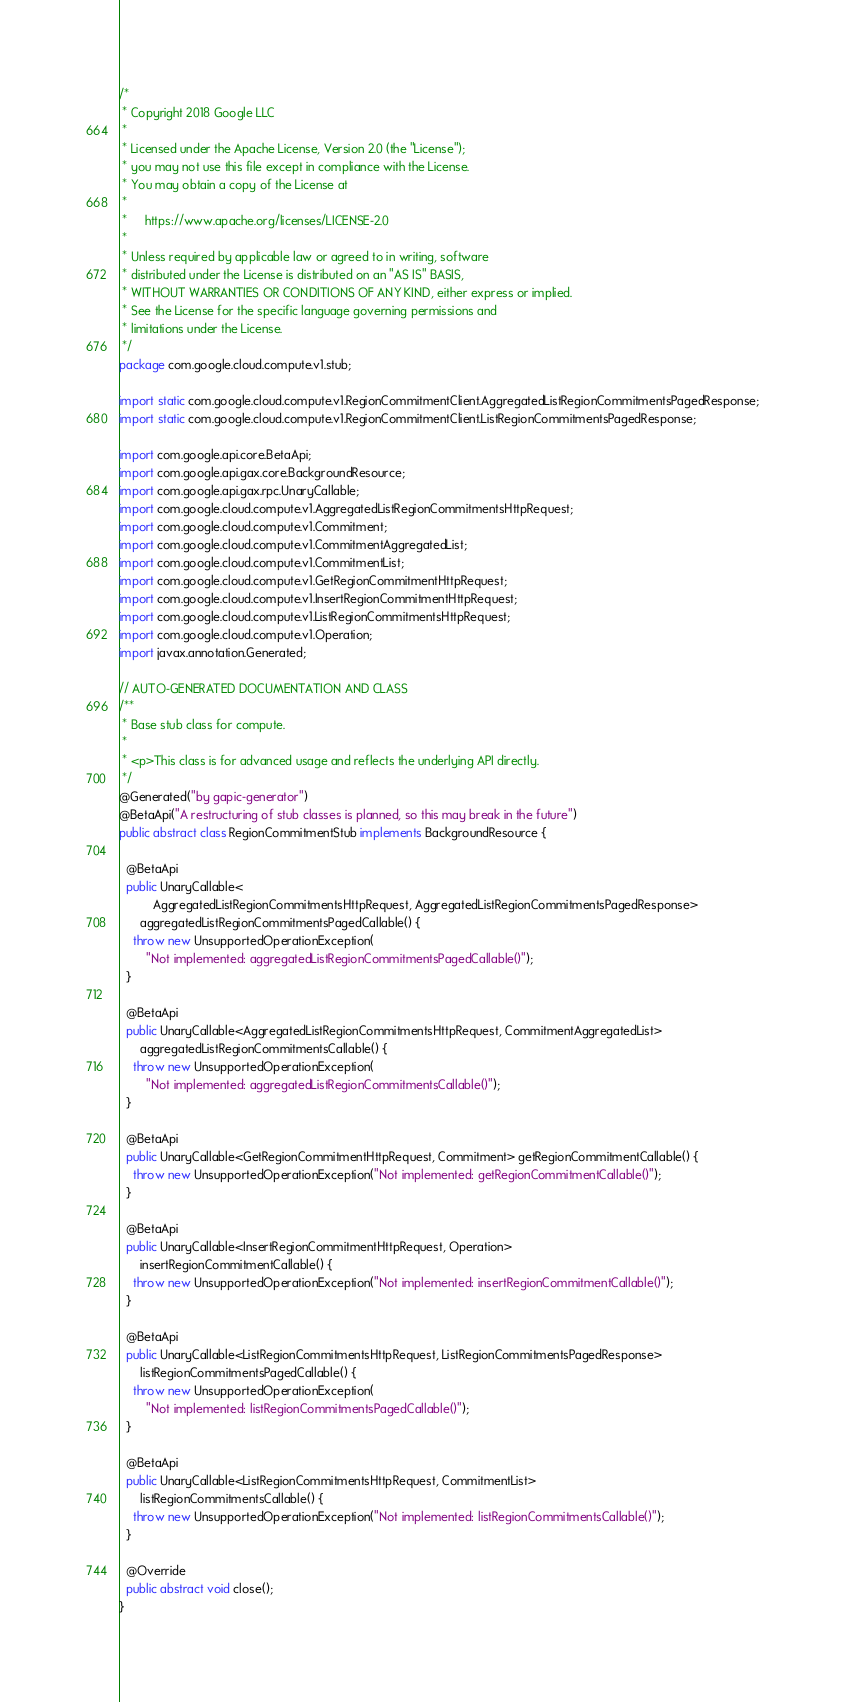Convert code to text. <code><loc_0><loc_0><loc_500><loc_500><_Java_>/*
 * Copyright 2018 Google LLC
 *
 * Licensed under the Apache License, Version 2.0 (the "License");
 * you may not use this file except in compliance with the License.
 * You may obtain a copy of the License at
 *
 *     https://www.apache.org/licenses/LICENSE-2.0
 *
 * Unless required by applicable law or agreed to in writing, software
 * distributed under the License is distributed on an "AS IS" BASIS,
 * WITHOUT WARRANTIES OR CONDITIONS OF ANY KIND, either express or implied.
 * See the License for the specific language governing permissions and
 * limitations under the License.
 */
package com.google.cloud.compute.v1.stub;

import static com.google.cloud.compute.v1.RegionCommitmentClient.AggregatedListRegionCommitmentsPagedResponse;
import static com.google.cloud.compute.v1.RegionCommitmentClient.ListRegionCommitmentsPagedResponse;

import com.google.api.core.BetaApi;
import com.google.api.gax.core.BackgroundResource;
import com.google.api.gax.rpc.UnaryCallable;
import com.google.cloud.compute.v1.AggregatedListRegionCommitmentsHttpRequest;
import com.google.cloud.compute.v1.Commitment;
import com.google.cloud.compute.v1.CommitmentAggregatedList;
import com.google.cloud.compute.v1.CommitmentList;
import com.google.cloud.compute.v1.GetRegionCommitmentHttpRequest;
import com.google.cloud.compute.v1.InsertRegionCommitmentHttpRequest;
import com.google.cloud.compute.v1.ListRegionCommitmentsHttpRequest;
import com.google.cloud.compute.v1.Operation;
import javax.annotation.Generated;

// AUTO-GENERATED DOCUMENTATION AND CLASS
/**
 * Base stub class for compute.
 *
 * <p>This class is for advanced usage and reflects the underlying API directly.
 */
@Generated("by gapic-generator")
@BetaApi("A restructuring of stub classes is planned, so this may break in the future")
public abstract class RegionCommitmentStub implements BackgroundResource {

  @BetaApi
  public UnaryCallable<
          AggregatedListRegionCommitmentsHttpRequest, AggregatedListRegionCommitmentsPagedResponse>
      aggregatedListRegionCommitmentsPagedCallable() {
    throw new UnsupportedOperationException(
        "Not implemented: aggregatedListRegionCommitmentsPagedCallable()");
  }

  @BetaApi
  public UnaryCallable<AggregatedListRegionCommitmentsHttpRequest, CommitmentAggregatedList>
      aggregatedListRegionCommitmentsCallable() {
    throw new UnsupportedOperationException(
        "Not implemented: aggregatedListRegionCommitmentsCallable()");
  }

  @BetaApi
  public UnaryCallable<GetRegionCommitmentHttpRequest, Commitment> getRegionCommitmentCallable() {
    throw new UnsupportedOperationException("Not implemented: getRegionCommitmentCallable()");
  }

  @BetaApi
  public UnaryCallable<InsertRegionCommitmentHttpRequest, Operation>
      insertRegionCommitmentCallable() {
    throw new UnsupportedOperationException("Not implemented: insertRegionCommitmentCallable()");
  }

  @BetaApi
  public UnaryCallable<ListRegionCommitmentsHttpRequest, ListRegionCommitmentsPagedResponse>
      listRegionCommitmentsPagedCallable() {
    throw new UnsupportedOperationException(
        "Not implemented: listRegionCommitmentsPagedCallable()");
  }

  @BetaApi
  public UnaryCallable<ListRegionCommitmentsHttpRequest, CommitmentList>
      listRegionCommitmentsCallable() {
    throw new UnsupportedOperationException("Not implemented: listRegionCommitmentsCallable()");
  }

  @Override
  public abstract void close();
}
</code> 